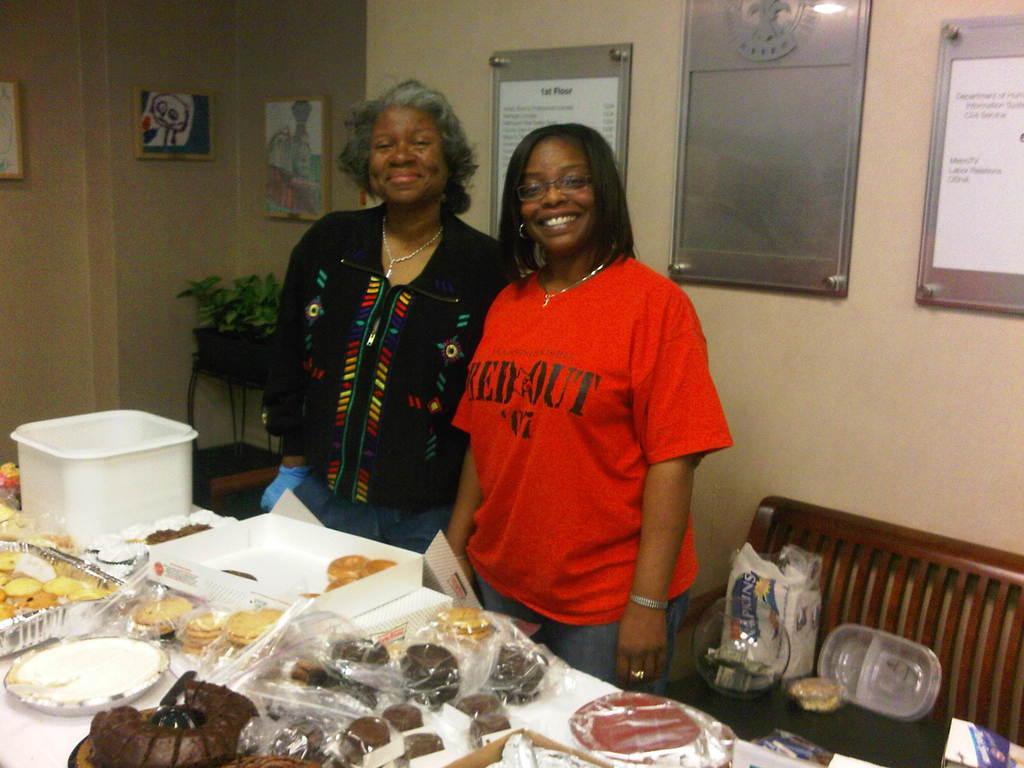In one or two sentences, can you explain what this image depicts? In this image there is a table, on that table there are food items and trays, beside the table there are two women standing, in the background there is a bench and a wall, for that wall there are posters and photo frames and there is a table on that table there is a pot. 